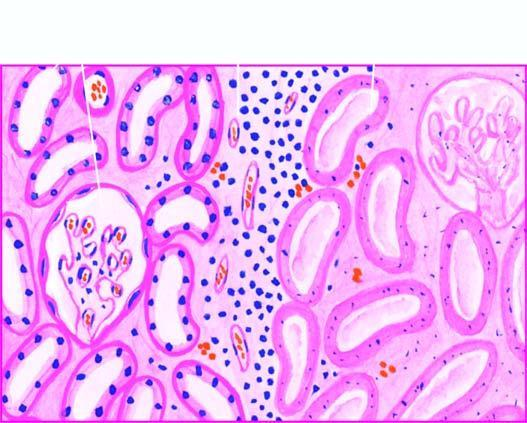what shows non-specific chronic inflammation and proliferating vessels?
Answer the question using a single word or phrase. The interface between viable non-viable area vessels 